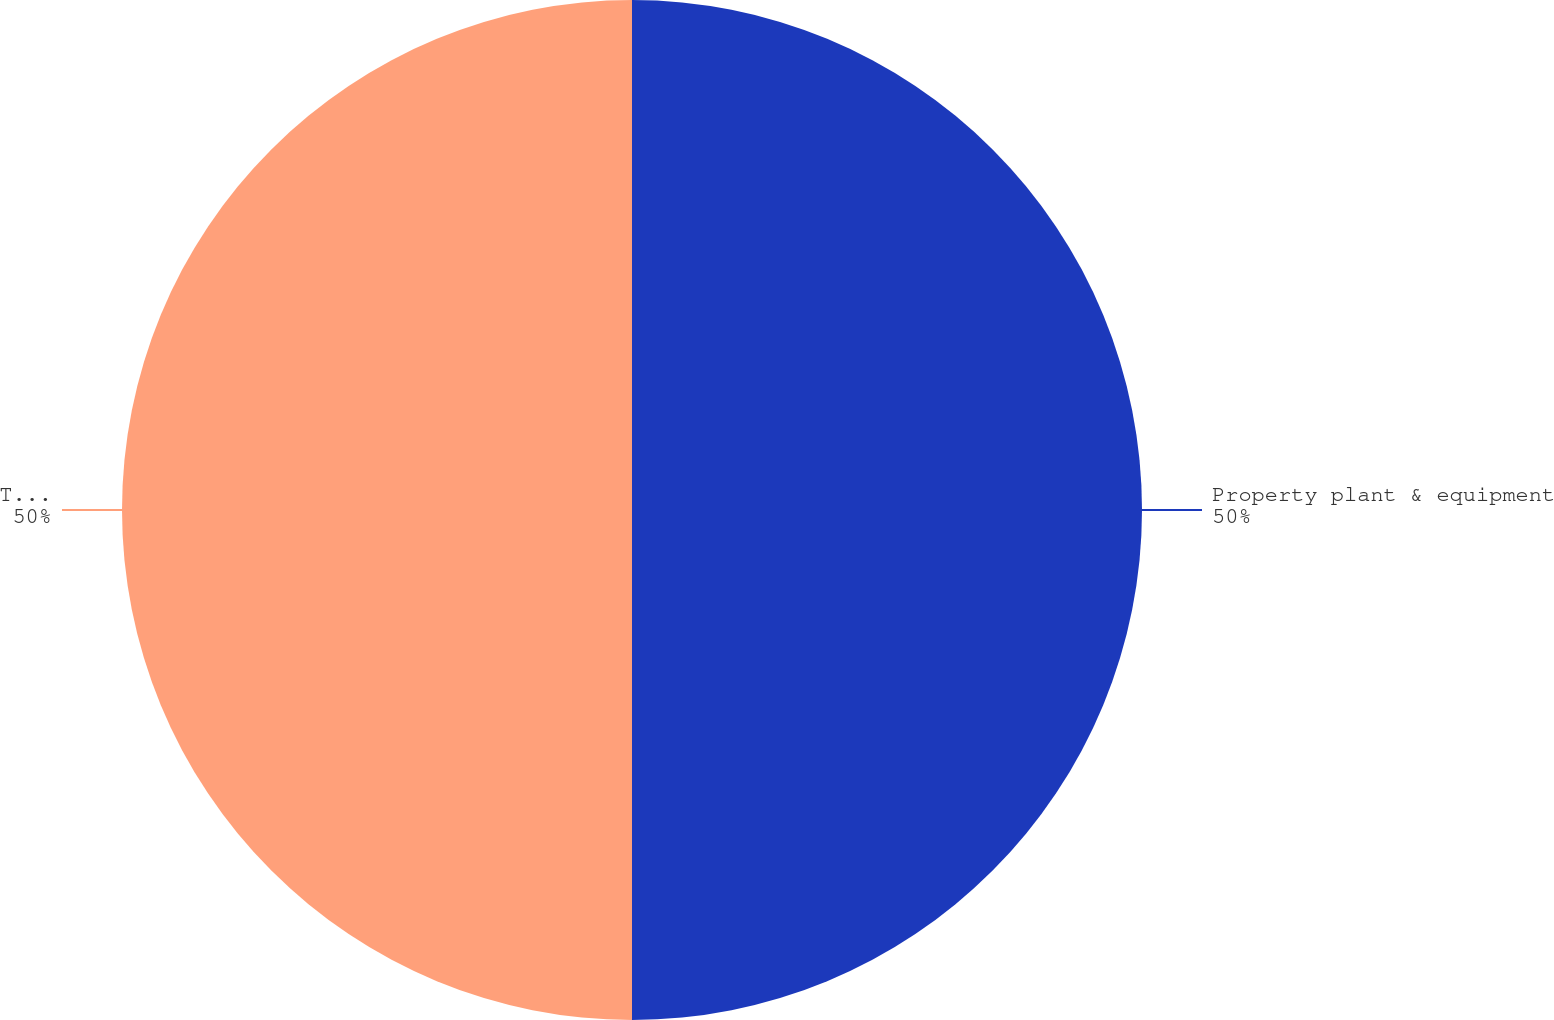<chart> <loc_0><loc_0><loc_500><loc_500><pie_chart><fcel>Property plant & equipment<fcel>Totals<nl><fcel>50.0%<fcel>50.0%<nl></chart> 